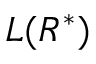Convert formula to latex. <formula><loc_0><loc_0><loc_500><loc_500>L ( R ^ { * } )</formula> 